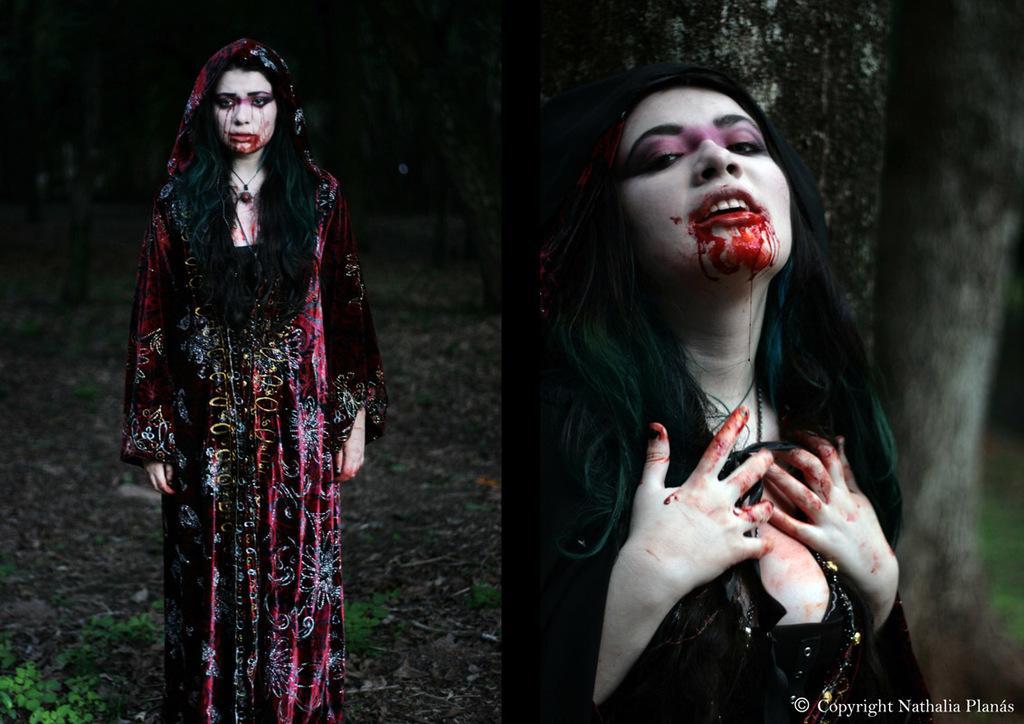Please provide a concise description of this image. In this image we can see there are two woman one on the left side and one on the right side and at the bottom left hand corner there are some leaves. 